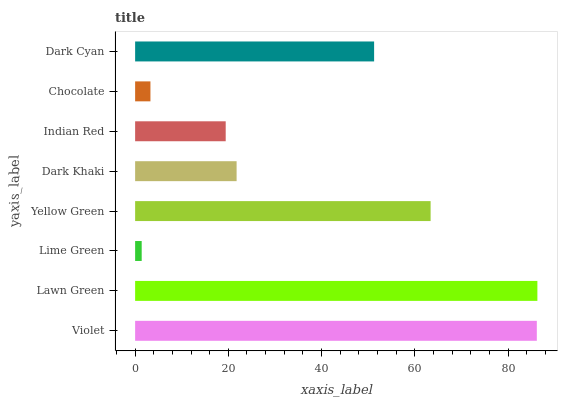Is Lime Green the minimum?
Answer yes or no. Yes. Is Lawn Green the maximum?
Answer yes or no. Yes. Is Lawn Green the minimum?
Answer yes or no. No. Is Lime Green the maximum?
Answer yes or no. No. Is Lawn Green greater than Lime Green?
Answer yes or no. Yes. Is Lime Green less than Lawn Green?
Answer yes or no. Yes. Is Lime Green greater than Lawn Green?
Answer yes or no. No. Is Lawn Green less than Lime Green?
Answer yes or no. No. Is Dark Cyan the high median?
Answer yes or no. Yes. Is Dark Khaki the low median?
Answer yes or no. Yes. Is Chocolate the high median?
Answer yes or no. No. Is Yellow Green the low median?
Answer yes or no. No. 